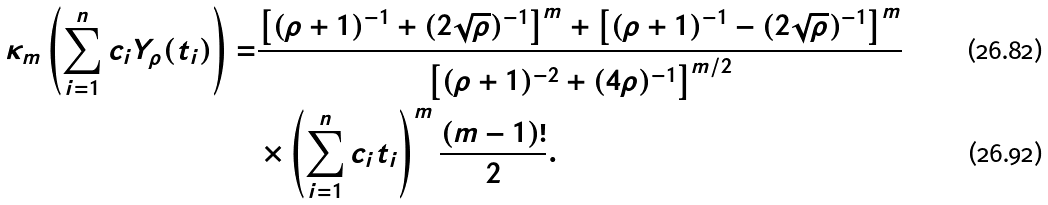Convert formula to latex. <formula><loc_0><loc_0><loc_500><loc_500>\kappa _ { m } \left ( \sum _ { i = 1 } ^ { n } c _ { i } Y _ { \rho } ( t _ { i } ) \right ) = & \frac { \left [ ( \rho + 1 ) ^ { - 1 } + ( 2 \sqrt { \rho } ) ^ { - 1 } \right ] ^ { m } + \left [ ( \rho + 1 ) ^ { - 1 } - ( 2 \sqrt { \rho } ) ^ { - 1 } \right ] ^ { m } } { \left [ ( \rho + 1 ) ^ { - 2 } + ( 4 \rho ) ^ { - 1 } \right ] ^ { m / 2 } } \\ & \times \left ( \sum _ { i = 1 } ^ { n } c _ { i } t _ { i } \right ) ^ { m } \frac { ( m - 1 ) ! } { 2 } .</formula> 